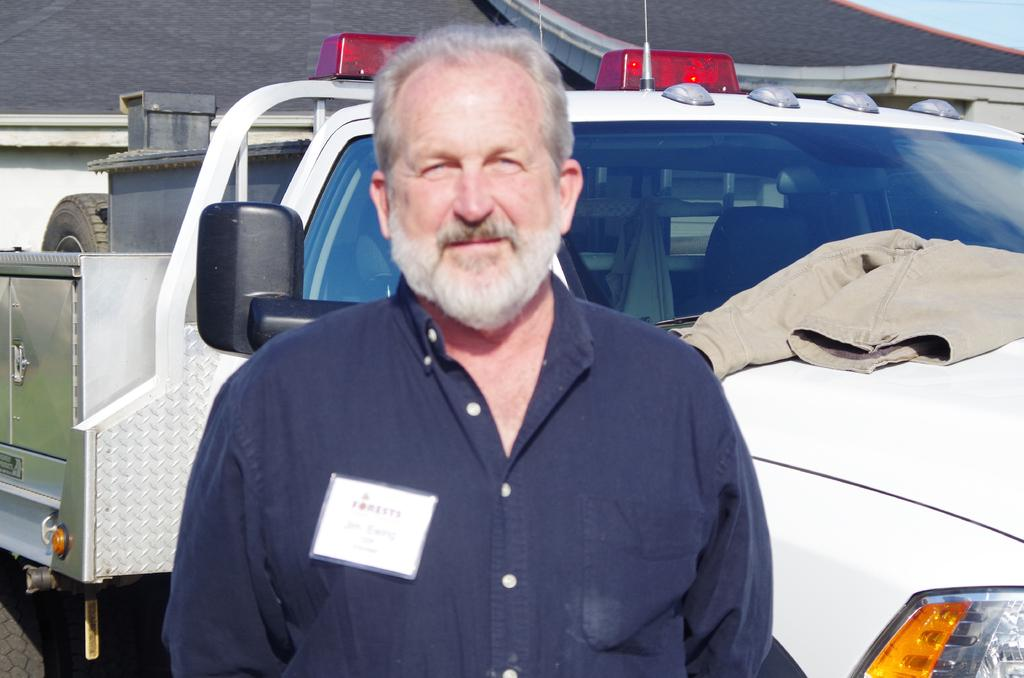Who is present in the image? There is a man in the image. What can be seen in the background of the image? There is a jeep and a house in the background of the image. What type of insect is crawling on the man's shoulder in the image? There is no insect present on the man's shoulder in the image. 